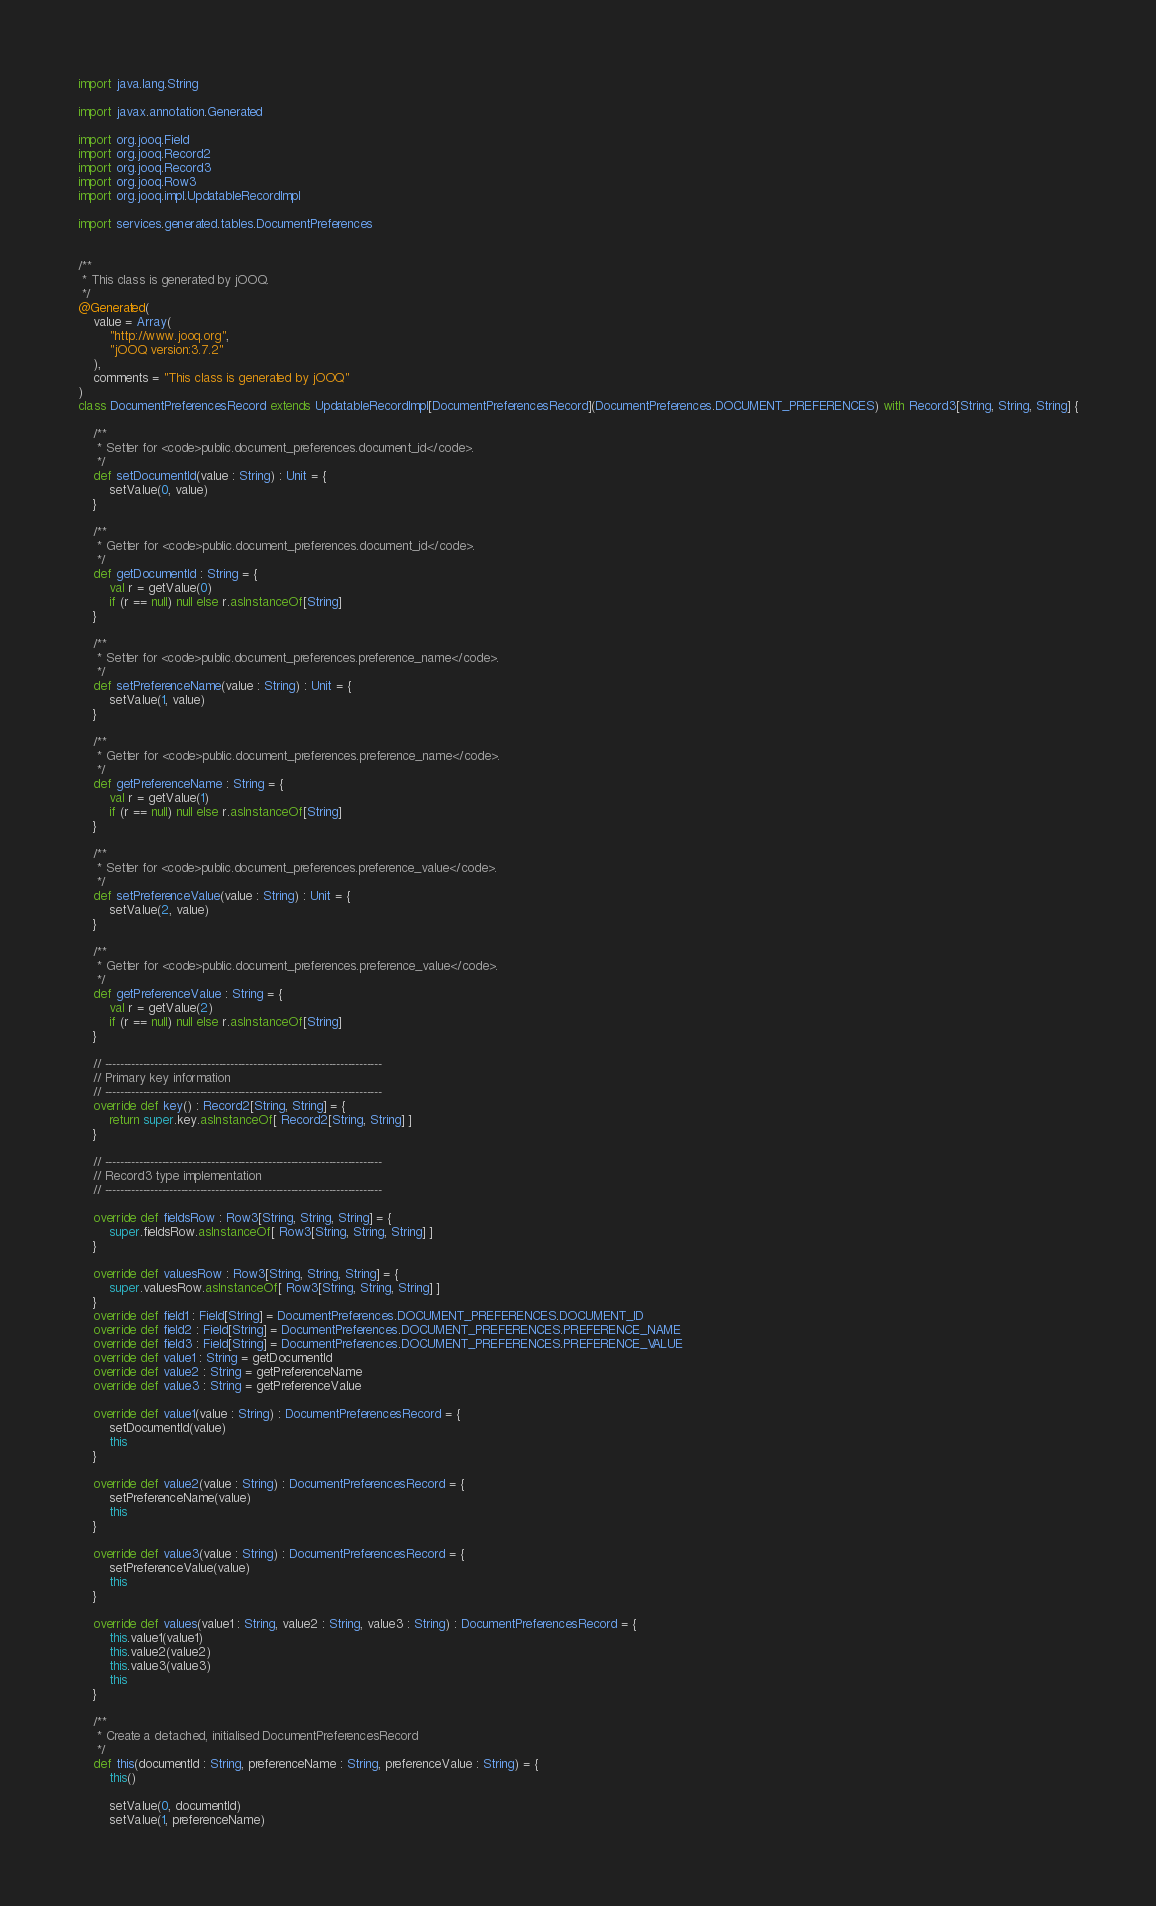Convert code to text. <code><loc_0><loc_0><loc_500><loc_500><_Scala_>import java.lang.String

import javax.annotation.Generated

import org.jooq.Field
import org.jooq.Record2
import org.jooq.Record3
import org.jooq.Row3
import org.jooq.impl.UpdatableRecordImpl

import services.generated.tables.DocumentPreferences


/**
 * This class is generated by jOOQ.
 */
@Generated(
	value = Array(
		"http://www.jooq.org",
		"jOOQ version:3.7.2"
	),
	comments = "This class is generated by jOOQ"
)
class DocumentPreferencesRecord extends UpdatableRecordImpl[DocumentPreferencesRecord](DocumentPreferences.DOCUMENT_PREFERENCES) with Record3[String, String, String] {

	/**
	 * Setter for <code>public.document_preferences.document_id</code>.
	 */
	def setDocumentId(value : String) : Unit = {
		setValue(0, value)
	}

	/**
	 * Getter for <code>public.document_preferences.document_id</code>.
	 */
	def getDocumentId : String = {
		val r = getValue(0)
		if (r == null) null else r.asInstanceOf[String]
	}

	/**
	 * Setter for <code>public.document_preferences.preference_name</code>.
	 */
	def setPreferenceName(value : String) : Unit = {
		setValue(1, value)
	}

	/**
	 * Getter for <code>public.document_preferences.preference_name</code>.
	 */
	def getPreferenceName : String = {
		val r = getValue(1)
		if (r == null) null else r.asInstanceOf[String]
	}

	/**
	 * Setter for <code>public.document_preferences.preference_value</code>.
	 */
	def setPreferenceValue(value : String) : Unit = {
		setValue(2, value)
	}

	/**
	 * Getter for <code>public.document_preferences.preference_value</code>.
	 */
	def getPreferenceValue : String = {
		val r = getValue(2)
		if (r == null) null else r.asInstanceOf[String]
	}

	// -------------------------------------------------------------------------
	// Primary key information
	// -------------------------------------------------------------------------
	override def key() : Record2[String, String] = {
		return super.key.asInstanceOf[ Record2[String, String] ]
	}

	// -------------------------------------------------------------------------
	// Record3 type implementation
	// -------------------------------------------------------------------------

	override def fieldsRow : Row3[String, String, String] = {
		super.fieldsRow.asInstanceOf[ Row3[String, String, String] ]
	}

	override def valuesRow : Row3[String, String, String] = {
		super.valuesRow.asInstanceOf[ Row3[String, String, String] ]
	}
	override def field1 : Field[String] = DocumentPreferences.DOCUMENT_PREFERENCES.DOCUMENT_ID
	override def field2 : Field[String] = DocumentPreferences.DOCUMENT_PREFERENCES.PREFERENCE_NAME
	override def field3 : Field[String] = DocumentPreferences.DOCUMENT_PREFERENCES.PREFERENCE_VALUE
	override def value1 : String = getDocumentId
	override def value2 : String = getPreferenceName
	override def value3 : String = getPreferenceValue

	override def value1(value : String) : DocumentPreferencesRecord = {
		setDocumentId(value)
		this
	}

	override def value2(value : String) : DocumentPreferencesRecord = {
		setPreferenceName(value)
		this
	}

	override def value3(value : String) : DocumentPreferencesRecord = {
		setPreferenceValue(value)
		this
	}

	override def values(value1 : String, value2 : String, value3 : String) : DocumentPreferencesRecord = {
		this.value1(value1)
		this.value2(value2)
		this.value3(value3)
		this
	}

	/**
	 * Create a detached, initialised DocumentPreferencesRecord
	 */
	def this(documentId : String, preferenceName : String, preferenceValue : String) = {
		this()

		setValue(0, documentId)
		setValue(1, preferenceName)</code> 